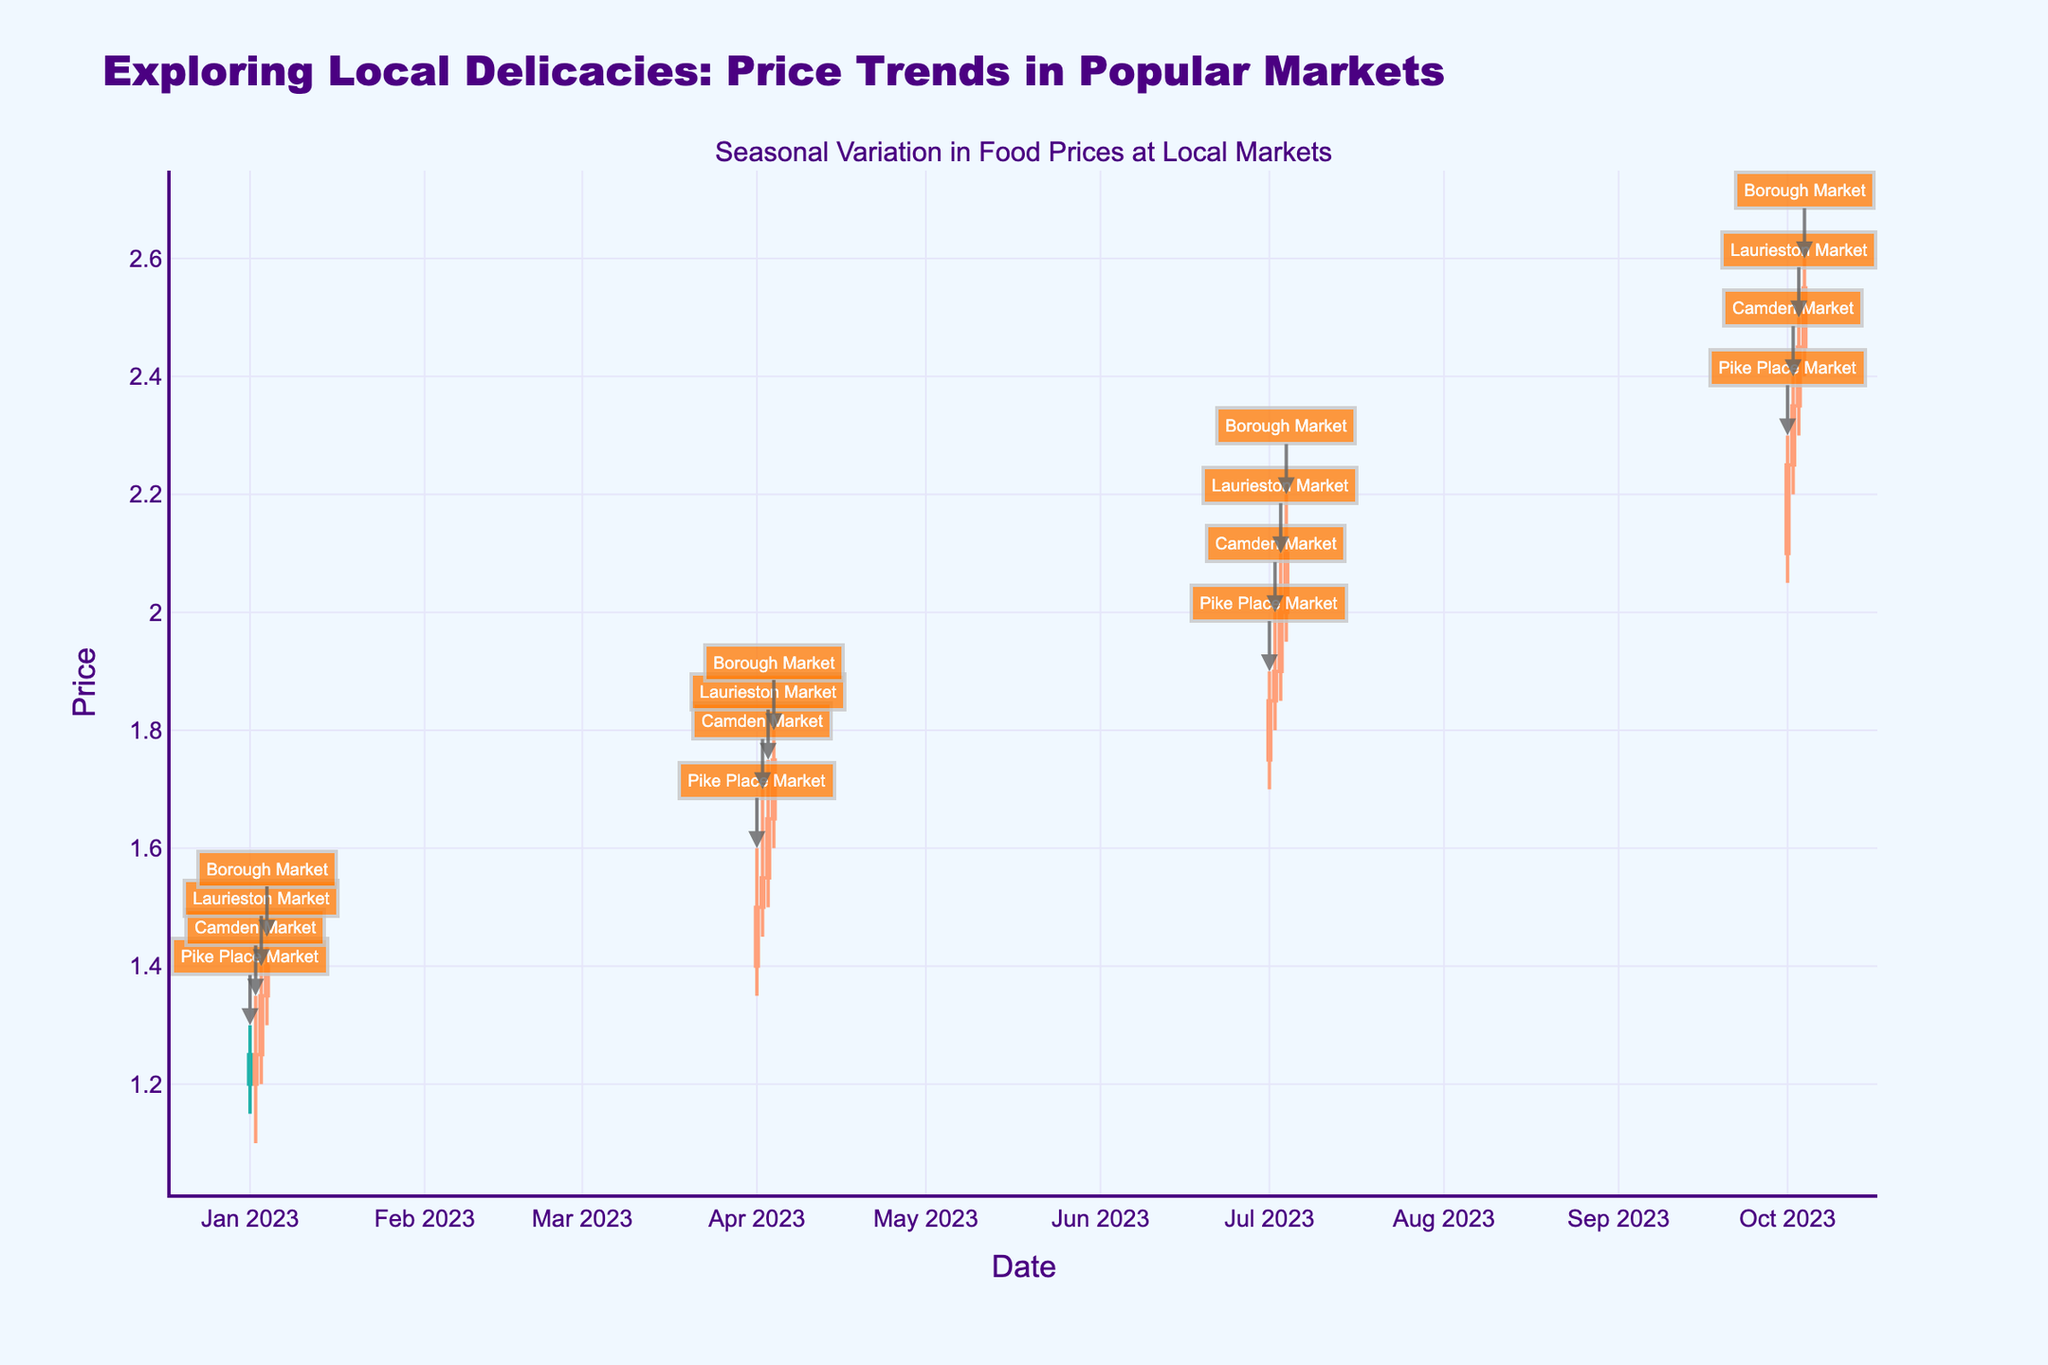What's the title of the figure? The title of the figure is prominently displayed at the top and reads "Exploring Local Delicacies: Price Trends in Popular Markets".
Answer: Exploring Local Delicacies: Price Trends in Popular Markets What is the y-axis title? The y-axis title is located next to the vertical axis and is labeled "Price".
Answer: Price Which market had the highest price on April 4, 2023? Look at the annotations and price values for April 4, 2023. Borough Market had the highest price with a high value of 1.80.
Answer: Borough Market What is the average closing price for Laurieston Market across all dates? Identify the closing prices of Laurieston Market: 1.35, 1.65, 2.00, 2.45. Sum these values to get a total of 7.45, then divide by the number of data points (4): 7.45 / 4 = 1.8625.
Answer: 1.86 Between Pike Place Market and Camden Market in July 2023, which had a higher closing price? Look at the closing prices for Pike Place Market and Camden Market on July 1, 2023, and July 2, 2023, respectively. Pike Place Market's closing price was 1.85, while Camden Market's was 1.90, indicating Camden Market had the higher price.
Answer: Camden Market For January 2023, which market had the lowest low price? Compare the low prices of each market in January 2023: Pike Place Market (1.15), Camden Market (1.10), Laurieston Market (1.20), Borough Market (1.30). Camden Market had the lowest low price of 1.10.
Answer: Camden Market How did the closing prices change from January to October for Borough Market? The closing price for Borough Market increased from 1.40 in January to 2.55 in October as observed from the candlestick plot.
Answer: Increased What is the range of prices (high minus low) for Pike Place Market on October 1, 2023? The high price on October 1, 2023, for Pike Place Market was 2.30 and the low was 2.05. Subtract the low from the high to get 2.30 - 2.05 = 0.25.
Answer: 0.25 Between April 1, 2023, and July 1, 2023, which market had the greatest increase in closing price? Observe the closing prices: Pike Place Market closed at 1.50 in April and 1.85 in July, an increase of 0.35. Camden Market closed at 1.55 in April and 1.90 in July, an increase of 0.35. Laurieston Market closed at 1.65 in April and 2.00 in July, an increase of 0.35. Borough Market closed at 1.75 in April and 2.10 in July, an increase of 0.35. All markets had an equal increase in closing price of 0.35.
Answer: All equal 